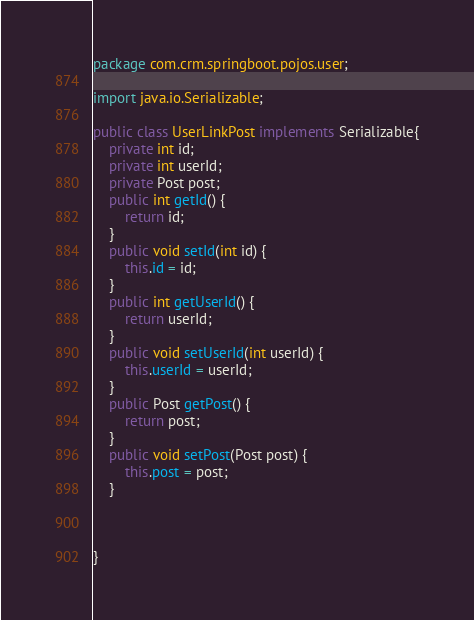<code> <loc_0><loc_0><loc_500><loc_500><_Java_>package com.crm.springboot.pojos.user;

import java.io.Serializable;

public class UserLinkPost implements Serializable{
	private int id;
	private int userId;
	private Post post;
	public int getId() {
		return id;
	}
	public void setId(int id) {
		this.id = id;
	}
	public int getUserId() {
		return userId;
	}
	public void setUserId(int userId) {
		this.userId = userId;
	}
	public Post getPost() {
		return post;
	}
	public void setPost(Post post) {
		this.post = post;
	}
	

	
}
</code> 